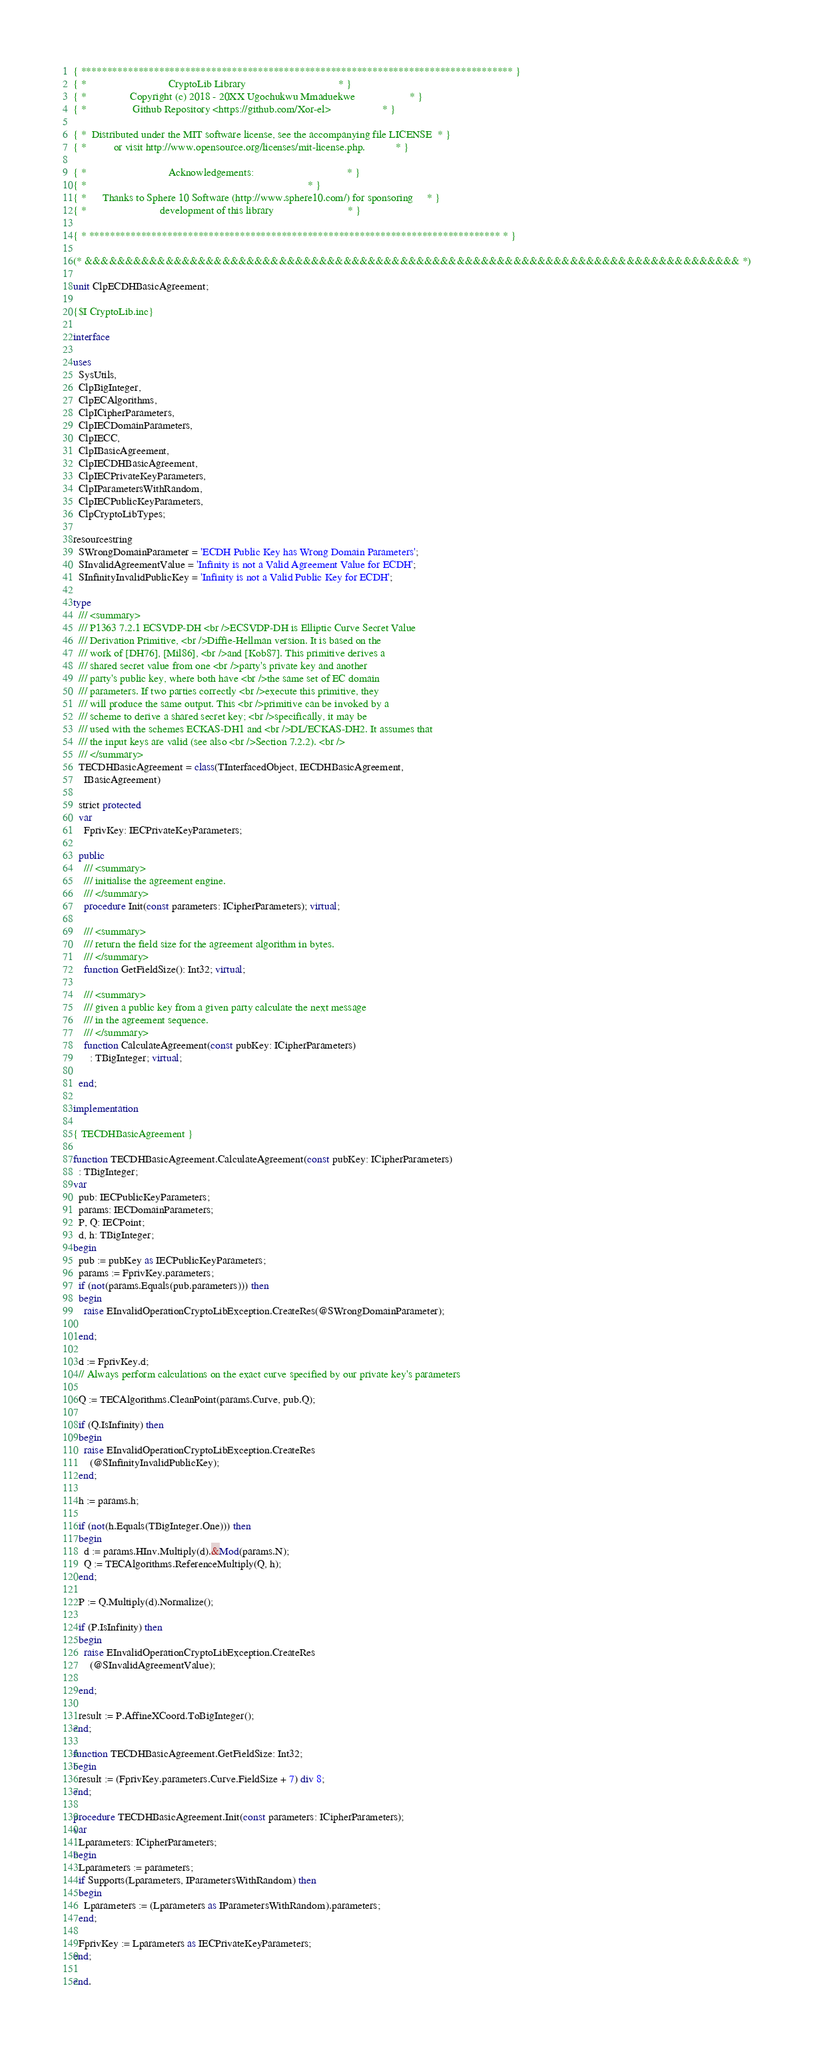<code> <loc_0><loc_0><loc_500><loc_500><_Pascal_>{ *********************************************************************************** }
{ *                              CryptoLib Library                                  * }
{ *                Copyright (c) 2018 - 20XX Ugochukwu Mmaduekwe                    * }
{ *                 Github Repository <https://github.com/Xor-el>                   * }

{ *  Distributed under the MIT software license, see the accompanying file LICENSE  * }
{ *          or visit http://www.opensource.org/licenses/mit-license.php.           * }

{ *                              Acknowledgements:                                  * }
{ *                                                                                 * }
{ *      Thanks to Sphere 10 Software (http://www.sphere10.com/) for sponsoring     * }
{ *                           development of this library                           * }

{ * ******************************************************************************* * }

(* &&&&&&&&&&&&&&&&&&&&&&&&&&&&&&&&&&&&&&&&&&&&&&&&&&&&&&&&&&&&&&&&&&&&&&&&&&&&&&&&& *)

unit ClpECDHBasicAgreement;

{$I CryptoLib.inc}

interface

uses
  SysUtils,
  ClpBigInteger,
  ClpECAlgorithms,
  ClpICipherParameters,
  ClpIECDomainParameters,
  ClpIECC,
  ClpIBasicAgreement,
  ClpIECDHBasicAgreement,
  ClpIECPrivateKeyParameters,
  ClpIParametersWithRandom,
  ClpIECPublicKeyParameters,
  ClpCryptoLibTypes;

resourcestring
  SWrongDomainParameter = 'ECDH Public Key has Wrong Domain Parameters';
  SInvalidAgreementValue = 'Infinity is not a Valid Agreement Value for ECDH';
  SInfinityInvalidPublicKey = 'Infinity is not a Valid Public Key for ECDH';

type
  /// <summary>
  /// P1363 7.2.1 ECSVDP-DH <br />ECSVDP-DH is Elliptic Curve Secret Value
  /// Derivation Primitive, <br />Diffie-Hellman version. It is based on the
  /// work of [DH76], [Mil86], <br />and [Kob87]. This primitive derives a
  /// shared secret value from one <br />party's private key and another
  /// party's public key, where both have <br />the same set of EC domain
  /// parameters. If two parties correctly <br />execute this primitive, they
  /// will produce the same output. This <br />primitive can be invoked by a
  /// scheme to derive a shared secret key; <br />specifically, it may be
  /// used with the schemes ECKAS-DH1 and <br />DL/ECKAS-DH2. It assumes that
  /// the input keys are valid (see also <br />Section 7.2.2). <br />
  /// </summary>
  TECDHBasicAgreement = class(TInterfacedObject, IECDHBasicAgreement,
    IBasicAgreement)

  strict protected
  var
    FprivKey: IECPrivateKeyParameters;

  public
    /// <summary>
    /// initialise the agreement engine.
    /// </summary>
    procedure Init(const parameters: ICipherParameters); virtual;

    /// <summary>
    /// return the field size for the agreement algorithm in bytes.
    /// </summary>
    function GetFieldSize(): Int32; virtual;

    /// <summary>
    /// given a public key from a given party calculate the next message
    /// in the agreement sequence.
    /// </summary>
    function CalculateAgreement(const pubKey: ICipherParameters)
      : TBigInteger; virtual;

  end;

implementation

{ TECDHBasicAgreement }

function TECDHBasicAgreement.CalculateAgreement(const pubKey: ICipherParameters)
  : TBigInteger;
var
  pub: IECPublicKeyParameters;
  params: IECDomainParameters;
  P, Q: IECPoint;
  d, h: TBigInteger;
begin
  pub := pubKey as IECPublicKeyParameters;
  params := FprivKey.parameters;
  if (not(params.Equals(pub.parameters))) then
  begin
    raise EInvalidOperationCryptoLibException.CreateRes(@SWrongDomainParameter);

  end;

  d := FprivKey.d;
  // Always perform calculations on the exact curve specified by our private key's parameters

  Q := TECAlgorithms.CleanPoint(params.Curve, pub.Q);

  if (Q.IsInfinity) then
  begin
    raise EInvalidOperationCryptoLibException.CreateRes
      (@SInfinityInvalidPublicKey);
  end;

  h := params.h;

  if (not(h.Equals(TBigInteger.One))) then
  begin
    d := params.HInv.Multiply(d).&Mod(params.N);
    Q := TECAlgorithms.ReferenceMultiply(Q, h);
  end;

  P := Q.Multiply(d).Normalize();

  if (P.IsInfinity) then
  begin
    raise EInvalidOperationCryptoLibException.CreateRes
      (@SInvalidAgreementValue);

  end;

  result := P.AffineXCoord.ToBigInteger();
end;

function TECDHBasicAgreement.GetFieldSize: Int32;
begin
  result := (FprivKey.parameters.Curve.FieldSize + 7) div 8;
end;

procedure TECDHBasicAgreement.Init(const parameters: ICipherParameters);
var
  Lparameters: ICipherParameters;
begin
  Lparameters := parameters;
  if Supports(Lparameters, IParametersWithRandom) then
  begin
    Lparameters := (Lparameters as IParametersWithRandom).parameters;
  end;

  FprivKey := Lparameters as IECPrivateKeyParameters;
end;

end.
</code> 